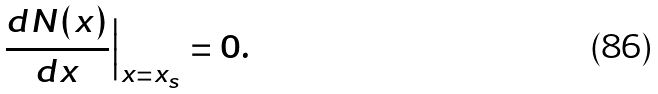Convert formula to latex. <formula><loc_0><loc_0><loc_500><loc_500>\frac { d N ( x ) } { d x } \Big { | } _ { x = x _ { s } } = 0 .</formula> 